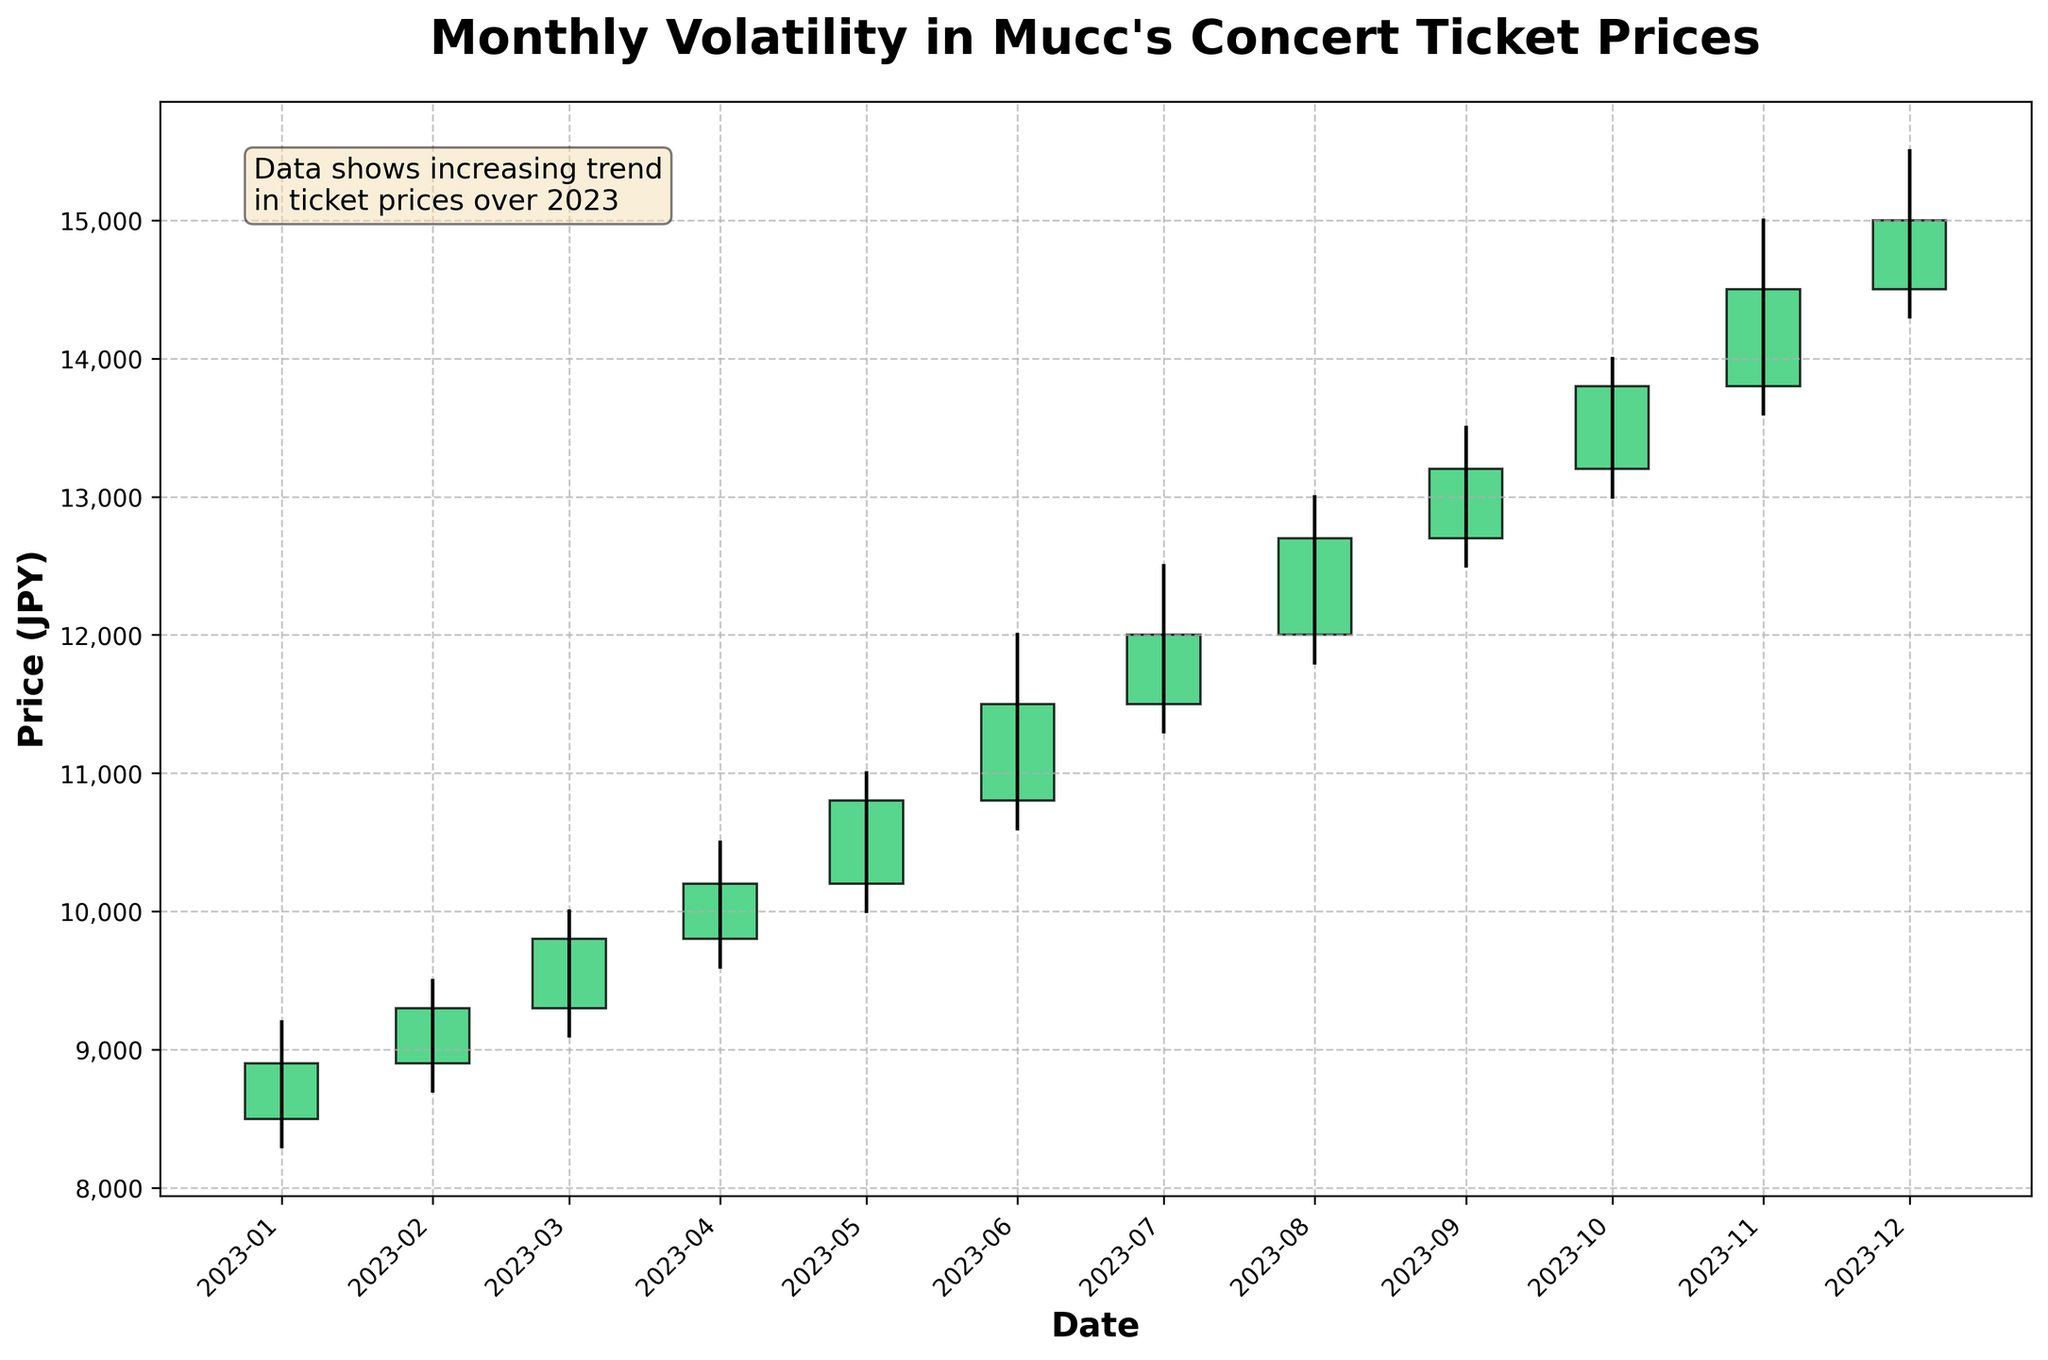What is the title of the chart? The title is located at the top of the chart. It reads "Monthly Volatility in Mucc's Concert Ticket Prices".
Answer: Monthly Volatility in Mucc's Concert Ticket Prices How many months are shown in the chart? The x-axis represents the dates, from 2023-01 to 2023-12. Each tick marks the beginning of a new month.
Answer: 12 Which months have the highest and lowest opening prices? By scanning the green and red rectangles, where the top represents the opening price for each month, we observe that November has the highest opening price of 13800 JPY and January has the lowest opening price of 8500 JPY.
Answer: November (highest), January (lowest) What is the average closing price of the tickets over the year? The closing prices for each month are: 8900, 9300, 9800, 10200, 10800, 11500, 12000, 12700, 13200, 13800, 14500, and 15000. Sum these values and divide by 12. The total is 143600, so the average is 143600 / 12 = 11966.67 JPY.
Answer: 11966.67 JPY Which month shows the largest price volatility? Volatility is measured by the difference between the high and low prices. We calculate this difference for each month: January (9200-8300=900), February (9500-8700=800), March (10000-9100=900), April (10500-9600=900), May (11000-10000=1000), June (12000-10600=1400), July (12500-11300=1200), August (13000-11800=1200), September (13500-12500=1000), October (14000-13000=1000), November (15000-13600=1400), December (15500-14300=1200). The largest difference is in June and November with 1400 JPY.
Answer: June and November Is there a month where the closing price is lower than the opening price? By examining the colors (red for decreasing), we can see that there are no red bodies in the chart. This indicates all months have closing prices equal to or higher than the opening prices.
Answer: No What is the difference in closing prices between the beginning and the end of the year? The closing prices are 8900 JPY in January and 15000 JPY in December. The difference is 15000 - 8900 = 6100 JPY.
Answer: 6100 JPY How does the chart indicate that the ticket prices increased over the year? The chart uses a series of green rectangles that consistently start at a higher position each month, ending at a higher value in December than in January. The additional textbox also notes an increasing trend.
Answer: Consistent rise in green rectangles and text box indication 